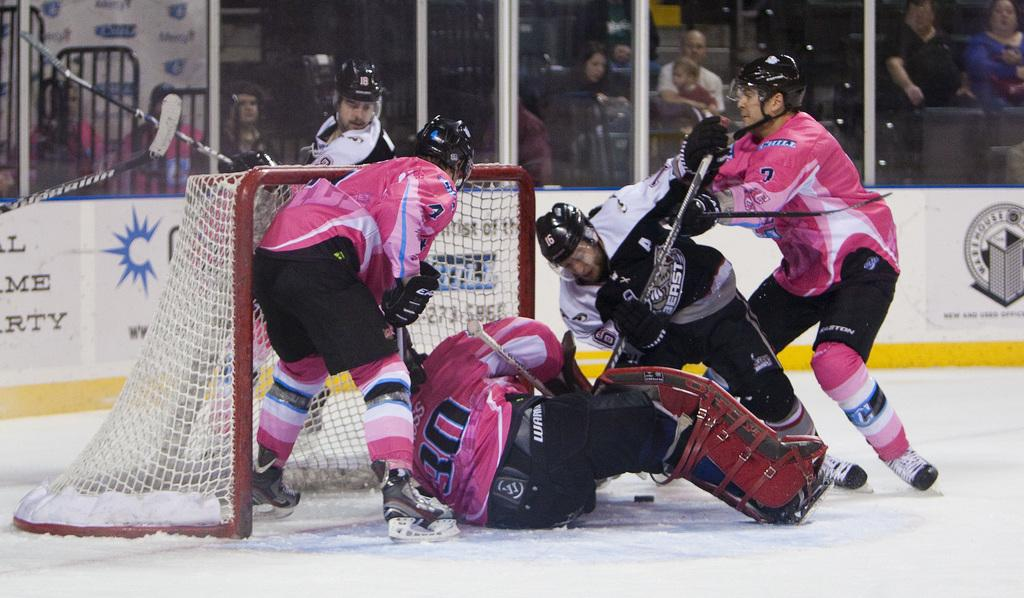<image>
Describe the image concisely. the man wearing number 16 helmet of the black team is hitting another man 